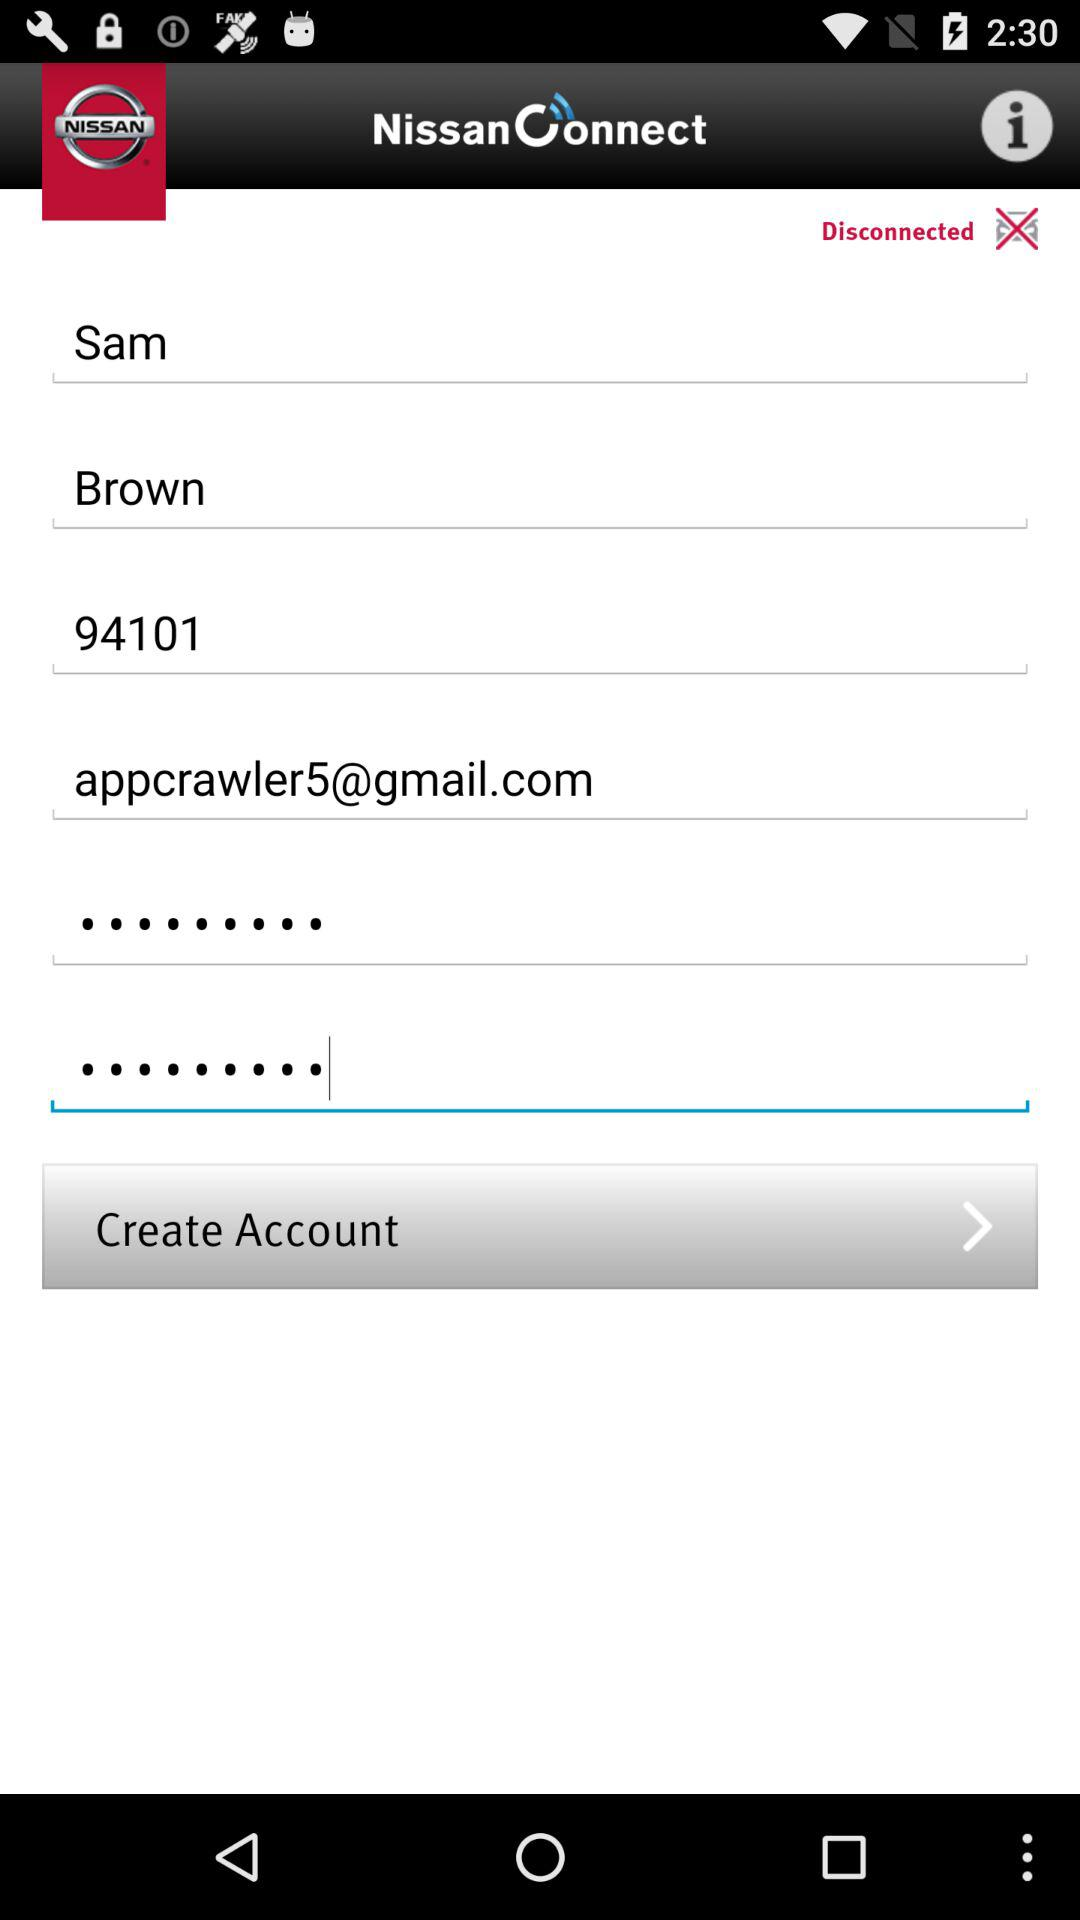What is the name? The name is Sam Brown. 